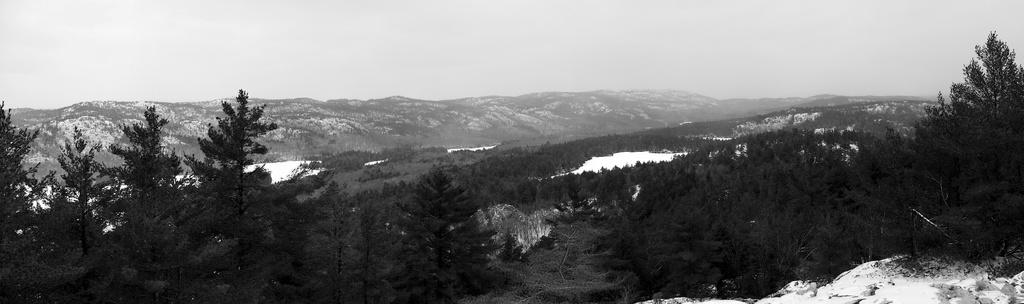What type of weather condition is depicted in the image? There is snow in the image, indicating a cold or wintry weather condition. What natural elements can be seen in the image? There are trees and mountains in the image. What is visible in the sky in the image? The sky is visible in the image. What type of pie is being served at the picnic in the image? There is no picnic or pie present in the image; it features snow, trees, mountains, and the sky. Can you see an arch in the image? There is no arch present in the image. 